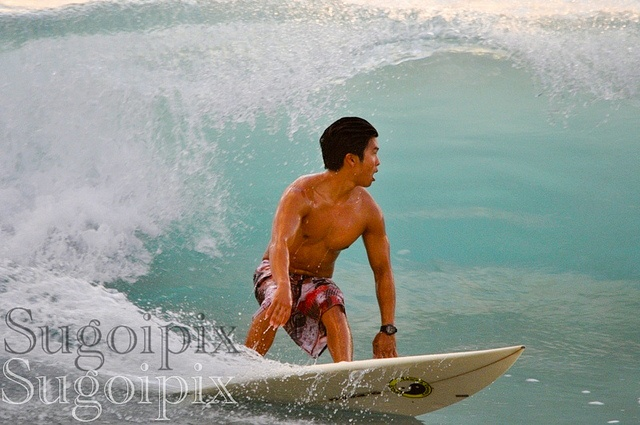Describe the objects in this image and their specific colors. I can see people in lightgray, brown, maroon, and black tones and surfboard in lightgray, gray, olive, and darkgray tones in this image. 